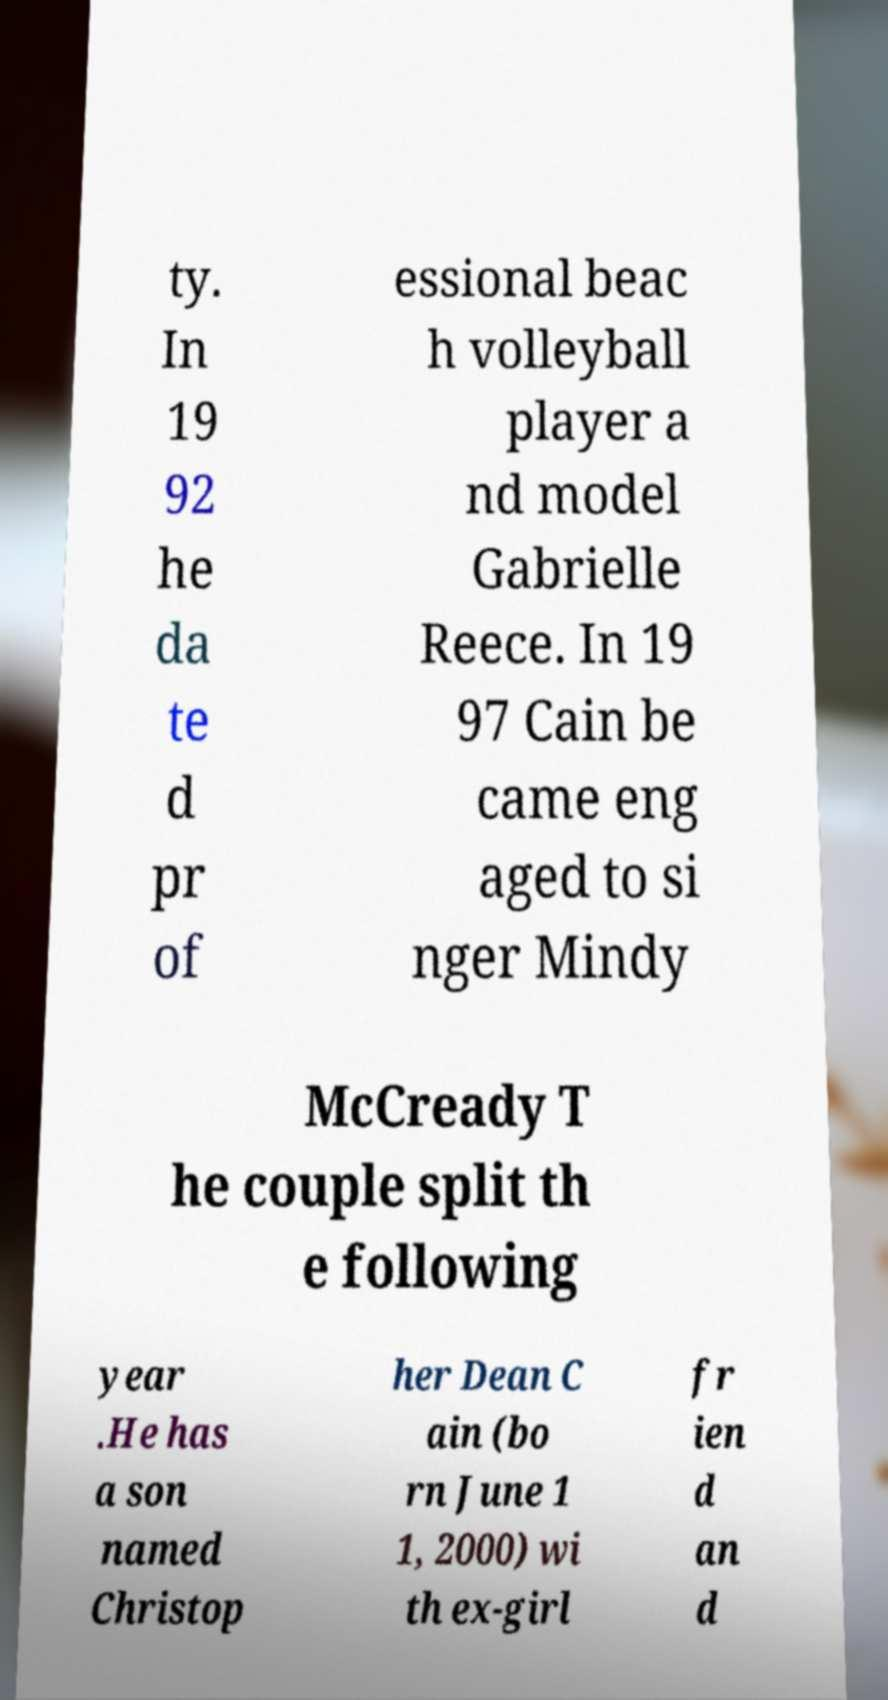Please identify and transcribe the text found in this image. ty. In 19 92 he da te d pr of essional beac h volleyball player a nd model Gabrielle Reece. In 19 97 Cain be came eng aged to si nger Mindy McCready T he couple split th e following year .He has a son named Christop her Dean C ain (bo rn June 1 1, 2000) wi th ex-girl fr ien d an d 